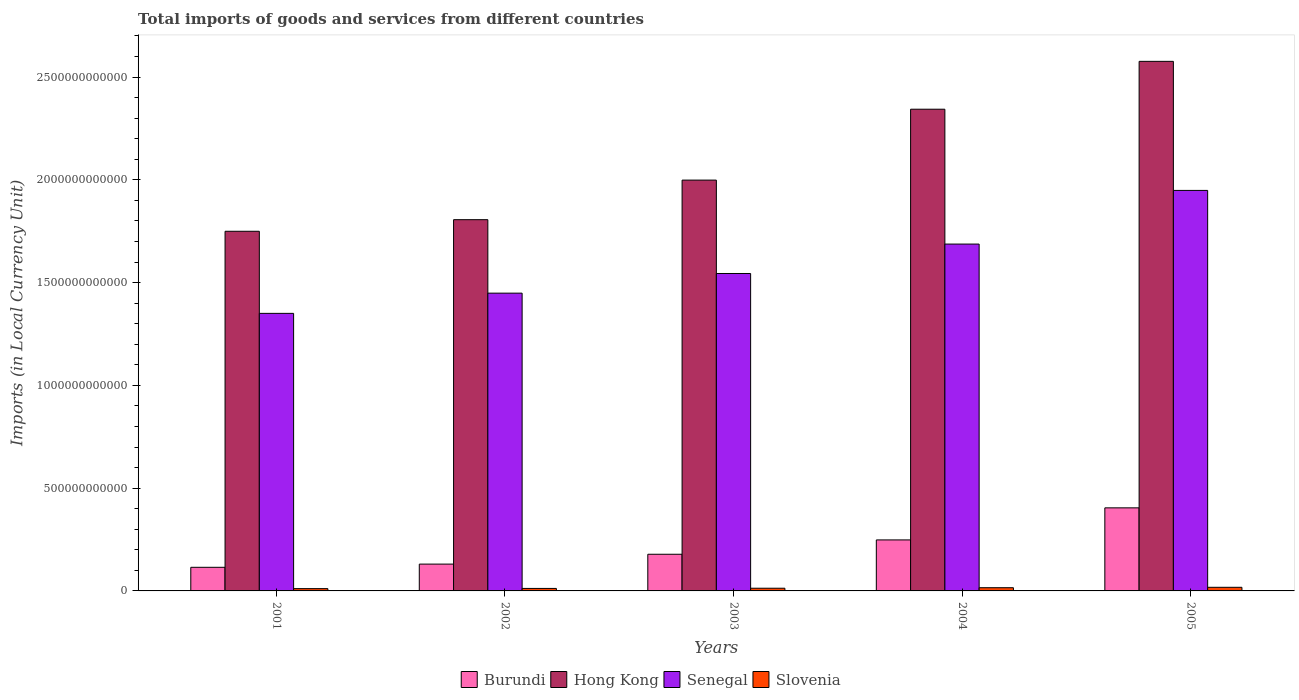How many different coloured bars are there?
Your answer should be very brief. 4. How many groups of bars are there?
Give a very brief answer. 5. How many bars are there on the 5th tick from the right?
Provide a succinct answer. 4. What is the label of the 4th group of bars from the left?
Your answer should be compact. 2004. In how many cases, is the number of bars for a given year not equal to the number of legend labels?
Give a very brief answer. 0. What is the Amount of goods and services imports in Hong Kong in 2001?
Give a very brief answer. 1.75e+12. Across all years, what is the maximum Amount of goods and services imports in Slovenia?
Provide a succinct answer. 1.76e+1. Across all years, what is the minimum Amount of goods and services imports in Senegal?
Your answer should be very brief. 1.35e+12. In which year was the Amount of goods and services imports in Hong Kong maximum?
Provide a short and direct response. 2005. What is the total Amount of goods and services imports in Slovenia in the graph?
Provide a succinct answer. 6.96e+1. What is the difference between the Amount of goods and services imports in Hong Kong in 2001 and that in 2003?
Keep it short and to the point. -2.49e+11. What is the difference between the Amount of goods and services imports in Burundi in 2003 and the Amount of goods and services imports in Slovenia in 2001?
Provide a succinct answer. 1.67e+11. What is the average Amount of goods and services imports in Burundi per year?
Offer a terse response. 2.15e+11. In the year 2001, what is the difference between the Amount of goods and services imports in Hong Kong and Amount of goods and services imports in Senegal?
Your response must be concise. 3.99e+11. What is the ratio of the Amount of goods and services imports in Senegal in 2001 to that in 2003?
Keep it short and to the point. 0.87. Is the Amount of goods and services imports in Senegal in 2003 less than that in 2004?
Your answer should be very brief. Yes. Is the difference between the Amount of goods and services imports in Hong Kong in 2003 and 2004 greater than the difference between the Amount of goods and services imports in Senegal in 2003 and 2004?
Keep it short and to the point. No. What is the difference between the highest and the second highest Amount of goods and services imports in Hong Kong?
Offer a very short reply. 2.33e+11. What is the difference between the highest and the lowest Amount of goods and services imports in Slovenia?
Provide a short and direct response. 6.44e+09. What does the 1st bar from the left in 2002 represents?
Ensure brevity in your answer.  Burundi. What does the 1st bar from the right in 2003 represents?
Ensure brevity in your answer.  Slovenia. Is it the case that in every year, the sum of the Amount of goods and services imports in Senegal and Amount of goods and services imports in Hong Kong is greater than the Amount of goods and services imports in Slovenia?
Your answer should be very brief. Yes. How many bars are there?
Give a very brief answer. 20. Are all the bars in the graph horizontal?
Offer a very short reply. No. What is the difference between two consecutive major ticks on the Y-axis?
Provide a succinct answer. 5.00e+11. Where does the legend appear in the graph?
Ensure brevity in your answer.  Bottom center. How are the legend labels stacked?
Make the answer very short. Horizontal. What is the title of the graph?
Ensure brevity in your answer.  Total imports of goods and services from different countries. What is the label or title of the Y-axis?
Make the answer very short. Imports (in Local Currency Unit). What is the Imports (in Local Currency Unit) of Burundi in 2001?
Provide a short and direct response. 1.15e+11. What is the Imports (in Local Currency Unit) of Hong Kong in 2001?
Give a very brief answer. 1.75e+12. What is the Imports (in Local Currency Unit) of Senegal in 2001?
Your answer should be compact. 1.35e+12. What is the Imports (in Local Currency Unit) in Slovenia in 2001?
Your answer should be compact. 1.12e+1. What is the Imports (in Local Currency Unit) of Burundi in 2002?
Provide a short and direct response. 1.31e+11. What is the Imports (in Local Currency Unit) in Hong Kong in 2002?
Ensure brevity in your answer.  1.81e+12. What is the Imports (in Local Currency Unit) in Senegal in 2002?
Make the answer very short. 1.45e+12. What is the Imports (in Local Currency Unit) of Slovenia in 2002?
Offer a very short reply. 1.21e+1. What is the Imports (in Local Currency Unit) in Burundi in 2003?
Offer a terse response. 1.78e+11. What is the Imports (in Local Currency Unit) of Hong Kong in 2003?
Keep it short and to the point. 2.00e+12. What is the Imports (in Local Currency Unit) in Senegal in 2003?
Provide a short and direct response. 1.54e+12. What is the Imports (in Local Currency Unit) of Slovenia in 2003?
Keep it short and to the point. 1.31e+1. What is the Imports (in Local Currency Unit) of Burundi in 2004?
Your answer should be very brief. 2.48e+11. What is the Imports (in Local Currency Unit) of Hong Kong in 2004?
Provide a succinct answer. 2.34e+12. What is the Imports (in Local Currency Unit) of Senegal in 2004?
Offer a very short reply. 1.69e+12. What is the Imports (in Local Currency Unit) of Slovenia in 2004?
Your answer should be very brief. 1.56e+1. What is the Imports (in Local Currency Unit) in Burundi in 2005?
Your response must be concise. 4.04e+11. What is the Imports (in Local Currency Unit) in Hong Kong in 2005?
Offer a terse response. 2.58e+12. What is the Imports (in Local Currency Unit) of Senegal in 2005?
Offer a terse response. 1.95e+12. What is the Imports (in Local Currency Unit) in Slovenia in 2005?
Your answer should be very brief. 1.76e+1. Across all years, what is the maximum Imports (in Local Currency Unit) in Burundi?
Your answer should be very brief. 4.04e+11. Across all years, what is the maximum Imports (in Local Currency Unit) in Hong Kong?
Offer a very short reply. 2.58e+12. Across all years, what is the maximum Imports (in Local Currency Unit) of Senegal?
Keep it short and to the point. 1.95e+12. Across all years, what is the maximum Imports (in Local Currency Unit) in Slovenia?
Ensure brevity in your answer.  1.76e+1. Across all years, what is the minimum Imports (in Local Currency Unit) in Burundi?
Your response must be concise. 1.15e+11. Across all years, what is the minimum Imports (in Local Currency Unit) of Hong Kong?
Give a very brief answer. 1.75e+12. Across all years, what is the minimum Imports (in Local Currency Unit) of Senegal?
Your answer should be very brief. 1.35e+12. Across all years, what is the minimum Imports (in Local Currency Unit) of Slovenia?
Ensure brevity in your answer.  1.12e+1. What is the total Imports (in Local Currency Unit) in Burundi in the graph?
Ensure brevity in your answer.  1.08e+12. What is the total Imports (in Local Currency Unit) in Hong Kong in the graph?
Make the answer very short. 1.05e+13. What is the total Imports (in Local Currency Unit) in Senegal in the graph?
Offer a terse response. 7.98e+12. What is the total Imports (in Local Currency Unit) of Slovenia in the graph?
Your answer should be compact. 6.96e+1. What is the difference between the Imports (in Local Currency Unit) of Burundi in 2001 and that in 2002?
Provide a short and direct response. -1.56e+1. What is the difference between the Imports (in Local Currency Unit) of Hong Kong in 2001 and that in 2002?
Your answer should be compact. -5.64e+1. What is the difference between the Imports (in Local Currency Unit) of Senegal in 2001 and that in 2002?
Your response must be concise. -9.83e+1. What is the difference between the Imports (in Local Currency Unit) in Slovenia in 2001 and that in 2002?
Your answer should be compact. -9.24e+08. What is the difference between the Imports (in Local Currency Unit) in Burundi in 2001 and that in 2003?
Provide a short and direct response. -6.34e+1. What is the difference between the Imports (in Local Currency Unit) in Hong Kong in 2001 and that in 2003?
Give a very brief answer. -2.49e+11. What is the difference between the Imports (in Local Currency Unit) in Senegal in 2001 and that in 2003?
Provide a succinct answer. -1.94e+11. What is the difference between the Imports (in Local Currency Unit) of Slovenia in 2001 and that in 2003?
Your answer should be very brief. -1.98e+09. What is the difference between the Imports (in Local Currency Unit) of Burundi in 2001 and that in 2004?
Your answer should be compact. -1.33e+11. What is the difference between the Imports (in Local Currency Unit) of Hong Kong in 2001 and that in 2004?
Your response must be concise. -5.94e+11. What is the difference between the Imports (in Local Currency Unit) of Senegal in 2001 and that in 2004?
Keep it short and to the point. -3.37e+11. What is the difference between the Imports (in Local Currency Unit) in Slovenia in 2001 and that in 2004?
Keep it short and to the point. -4.45e+09. What is the difference between the Imports (in Local Currency Unit) of Burundi in 2001 and that in 2005?
Ensure brevity in your answer.  -2.89e+11. What is the difference between the Imports (in Local Currency Unit) of Hong Kong in 2001 and that in 2005?
Offer a terse response. -8.27e+11. What is the difference between the Imports (in Local Currency Unit) in Senegal in 2001 and that in 2005?
Your answer should be very brief. -5.98e+11. What is the difference between the Imports (in Local Currency Unit) of Slovenia in 2001 and that in 2005?
Keep it short and to the point. -6.44e+09. What is the difference between the Imports (in Local Currency Unit) of Burundi in 2002 and that in 2003?
Provide a short and direct response. -4.78e+1. What is the difference between the Imports (in Local Currency Unit) in Hong Kong in 2002 and that in 2003?
Provide a short and direct response. -1.93e+11. What is the difference between the Imports (in Local Currency Unit) of Senegal in 2002 and that in 2003?
Offer a terse response. -9.56e+1. What is the difference between the Imports (in Local Currency Unit) in Slovenia in 2002 and that in 2003?
Your answer should be compact. -1.06e+09. What is the difference between the Imports (in Local Currency Unit) in Burundi in 2002 and that in 2004?
Make the answer very short. -1.18e+11. What is the difference between the Imports (in Local Currency Unit) in Hong Kong in 2002 and that in 2004?
Make the answer very short. -5.37e+11. What is the difference between the Imports (in Local Currency Unit) in Senegal in 2002 and that in 2004?
Make the answer very short. -2.39e+11. What is the difference between the Imports (in Local Currency Unit) in Slovenia in 2002 and that in 2004?
Offer a terse response. -3.52e+09. What is the difference between the Imports (in Local Currency Unit) of Burundi in 2002 and that in 2005?
Provide a succinct answer. -2.74e+11. What is the difference between the Imports (in Local Currency Unit) of Hong Kong in 2002 and that in 2005?
Your answer should be compact. -7.70e+11. What is the difference between the Imports (in Local Currency Unit) in Senegal in 2002 and that in 2005?
Offer a terse response. -5.00e+11. What is the difference between the Imports (in Local Currency Unit) of Slovenia in 2002 and that in 2005?
Ensure brevity in your answer.  -5.51e+09. What is the difference between the Imports (in Local Currency Unit) in Burundi in 2003 and that in 2004?
Provide a succinct answer. -6.98e+1. What is the difference between the Imports (in Local Currency Unit) of Hong Kong in 2003 and that in 2004?
Keep it short and to the point. -3.45e+11. What is the difference between the Imports (in Local Currency Unit) in Senegal in 2003 and that in 2004?
Ensure brevity in your answer.  -1.43e+11. What is the difference between the Imports (in Local Currency Unit) of Slovenia in 2003 and that in 2004?
Your response must be concise. -2.47e+09. What is the difference between the Imports (in Local Currency Unit) in Burundi in 2003 and that in 2005?
Offer a terse response. -2.26e+11. What is the difference between the Imports (in Local Currency Unit) of Hong Kong in 2003 and that in 2005?
Ensure brevity in your answer.  -5.78e+11. What is the difference between the Imports (in Local Currency Unit) of Senegal in 2003 and that in 2005?
Provide a succinct answer. -4.04e+11. What is the difference between the Imports (in Local Currency Unit) in Slovenia in 2003 and that in 2005?
Your answer should be compact. -4.45e+09. What is the difference between the Imports (in Local Currency Unit) of Burundi in 2004 and that in 2005?
Offer a terse response. -1.56e+11. What is the difference between the Imports (in Local Currency Unit) of Hong Kong in 2004 and that in 2005?
Your answer should be very brief. -2.33e+11. What is the difference between the Imports (in Local Currency Unit) of Senegal in 2004 and that in 2005?
Make the answer very short. -2.61e+11. What is the difference between the Imports (in Local Currency Unit) in Slovenia in 2004 and that in 2005?
Offer a very short reply. -1.99e+09. What is the difference between the Imports (in Local Currency Unit) of Burundi in 2001 and the Imports (in Local Currency Unit) of Hong Kong in 2002?
Offer a terse response. -1.69e+12. What is the difference between the Imports (in Local Currency Unit) of Burundi in 2001 and the Imports (in Local Currency Unit) of Senegal in 2002?
Provide a succinct answer. -1.33e+12. What is the difference between the Imports (in Local Currency Unit) in Burundi in 2001 and the Imports (in Local Currency Unit) in Slovenia in 2002?
Your answer should be very brief. 1.03e+11. What is the difference between the Imports (in Local Currency Unit) of Hong Kong in 2001 and the Imports (in Local Currency Unit) of Senegal in 2002?
Your response must be concise. 3.01e+11. What is the difference between the Imports (in Local Currency Unit) of Hong Kong in 2001 and the Imports (in Local Currency Unit) of Slovenia in 2002?
Keep it short and to the point. 1.74e+12. What is the difference between the Imports (in Local Currency Unit) of Senegal in 2001 and the Imports (in Local Currency Unit) of Slovenia in 2002?
Ensure brevity in your answer.  1.34e+12. What is the difference between the Imports (in Local Currency Unit) of Burundi in 2001 and the Imports (in Local Currency Unit) of Hong Kong in 2003?
Make the answer very short. -1.88e+12. What is the difference between the Imports (in Local Currency Unit) of Burundi in 2001 and the Imports (in Local Currency Unit) of Senegal in 2003?
Provide a short and direct response. -1.43e+12. What is the difference between the Imports (in Local Currency Unit) in Burundi in 2001 and the Imports (in Local Currency Unit) in Slovenia in 2003?
Ensure brevity in your answer.  1.02e+11. What is the difference between the Imports (in Local Currency Unit) in Hong Kong in 2001 and the Imports (in Local Currency Unit) in Senegal in 2003?
Your answer should be compact. 2.05e+11. What is the difference between the Imports (in Local Currency Unit) of Hong Kong in 2001 and the Imports (in Local Currency Unit) of Slovenia in 2003?
Provide a succinct answer. 1.74e+12. What is the difference between the Imports (in Local Currency Unit) in Senegal in 2001 and the Imports (in Local Currency Unit) in Slovenia in 2003?
Your answer should be compact. 1.34e+12. What is the difference between the Imports (in Local Currency Unit) of Burundi in 2001 and the Imports (in Local Currency Unit) of Hong Kong in 2004?
Offer a terse response. -2.23e+12. What is the difference between the Imports (in Local Currency Unit) in Burundi in 2001 and the Imports (in Local Currency Unit) in Senegal in 2004?
Ensure brevity in your answer.  -1.57e+12. What is the difference between the Imports (in Local Currency Unit) in Burundi in 2001 and the Imports (in Local Currency Unit) in Slovenia in 2004?
Your answer should be compact. 9.93e+1. What is the difference between the Imports (in Local Currency Unit) in Hong Kong in 2001 and the Imports (in Local Currency Unit) in Senegal in 2004?
Provide a succinct answer. 6.23e+1. What is the difference between the Imports (in Local Currency Unit) of Hong Kong in 2001 and the Imports (in Local Currency Unit) of Slovenia in 2004?
Give a very brief answer. 1.73e+12. What is the difference between the Imports (in Local Currency Unit) in Senegal in 2001 and the Imports (in Local Currency Unit) in Slovenia in 2004?
Your answer should be compact. 1.33e+12. What is the difference between the Imports (in Local Currency Unit) of Burundi in 2001 and the Imports (in Local Currency Unit) of Hong Kong in 2005?
Give a very brief answer. -2.46e+12. What is the difference between the Imports (in Local Currency Unit) of Burundi in 2001 and the Imports (in Local Currency Unit) of Senegal in 2005?
Offer a very short reply. -1.83e+12. What is the difference between the Imports (in Local Currency Unit) of Burundi in 2001 and the Imports (in Local Currency Unit) of Slovenia in 2005?
Offer a terse response. 9.73e+1. What is the difference between the Imports (in Local Currency Unit) in Hong Kong in 2001 and the Imports (in Local Currency Unit) in Senegal in 2005?
Your response must be concise. -1.99e+11. What is the difference between the Imports (in Local Currency Unit) of Hong Kong in 2001 and the Imports (in Local Currency Unit) of Slovenia in 2005?
Your response must be concise. 1.73e+12. What is the difference between the Imports (in Local Currency Unit) of Senegal in 2001 and the Imports (in Local Currency Unit) of Slovenia in 2005?
Provide a short and direct response. 1.33e+12. What is the difference between the Imports (in Local Currency Unit) of Burundi in 2002 and the Imports (in Local Currency Unit) of Hong Kong in 2003?
Your answer should be very brief. -1.87e+12. What is the difference between the Imports (in Local Currency Unit) of Burundi in 2002 and the Imports (in Local Currency Unit) of Senegal in 2003?
Offer a terse response. -1.41e+12. What is the difference between the Imports (in Local Currency Unit) of Burundi in 2002 and the Imports (in Local Currency Unit) of Slovenia in 2003?
Give a very brief answer. 1.17e+11. What is the difference between the Imports (in Local Currency Unit) in Hong Kong in 2002 and the Imports (in Local Currency Unit) in Senegal in 2003?
Keep it short and to the point. 2.62e+11. What is the difference between the Imports (in Local Currency Unit) in Hong Kong in 2002 and the Imports (in Local Currency Unit) in Slovenia in 2003?
Ensure brevity in your answer.  1.79e+12. What is the difference between the Imports (in Local Currency Unit) of Senegal in 2002 and the Imports (in Local Currency Unit) of Slovenia in 2003?
Provide a short and direct response. 1.44e+12. What is the difference between the Imports (in Local Currency Unit) in Burundi in 2002 and the Imports (in Local Currency Unit) in Hong Kong in 2004?
Give a very brief answer. -2.21e+12. What is the difference between the Imports (in Local Currency Unit) of Burundi in 2002 and the Imports (in Local Currency Unit) of Senegal in 2004?
Provide a short and direct response. -1.56e+12. What is the difference between the Imports (in Local Currency Unit) of Burundi in 2002 and the Imports (in Local Currency Unit) of Slovenia in 2004?
Your response must be concise. 1.15e+11. What is the difference between the Imports (in Local Currency Unit) of Hong Kong in 2002 and the Imports (in Local Currency Unit) of Senegal in 2004?
Your answer should be very brief. 1.19e+11. What is the difference between the Imports (in Local Currency Unit) in Hong Kong in 2002 and the Imports (in Local Currency Unit) in Slovenia in 2004?
Your answer should be compact. 1.79e+12. What is the difference between the Imports (in Local Currency Unit) in Senegal in 2002 and the Imports (in Local Currency Unit) in Slovenia in 2004?
Give a very brief answer. 1.43e+12. What is the difference between the Imports (in Local Currency Unit) of Burundi in 2002 and the Imports (in Local Currency Unit) of Hong Kong in 2005?
Your answer should be very brief. -2.45e+12. What is the difference between the Imports (in Local Currency Unit) in Burundi in 2002 and the Imports (in Local Currency Unit) in Senegal in 2005?
Keep it short and to the point. -1.82e+12. What is the difference between the Imports (in Local Currency Unit) in Burundi in 2002 and the Imports (in Local Currency Unit) in Slovenia in 2005?
Offer a terse response. 1.13e+11. What is the difference between the Imports (in Local Currency Unit) of Hong Kong in 2002 and the Imports (in Local Currency Unit) of Senegal in 2005?
Offer a very short reply. -1.42e+11. What is the difference between the Imports (in Local Currency Unit) in Hong Kong in 2002 and the Imports (in Local Currency Unit) in Slovenia in 2005?
Your response must be concise. 1.79e+12. What is the difference between the Imports (in Local Currency Unit) in Senegal in 2002 and the Imports (in Local Currency Unit) in Slovenia in 2005?
Make the answer very short. 1.43e+12. What is the difference between the Imports (in Local Currency Unit) of Burundi in 2003 and the Imports (in Local Currency Unit) of Hong Kong in 2004?
Ensure brevity in your answer.  -2.17e+12. What is the difference between the Imports (in Local Currency Unit) in Burundi in 2003 and the Imports (in Local Currency Unit) in Senegal in 2004?
Offer a very short reply. -1.51e+12. What is the difference between the Imports (in Local Currency Unit) in Burundi in 2003 and the Imports (in Local Currency Unit) in Slovenia in 2004?
Your answer should be compact. 1.63e+11. What is the difference between the Imports (in Local Currency Unit) of Hong Kong in 2003 and the Imports (in Local Currency Unit) of Senegal in 2004?
Make the answer very short. 3.11e+11. What is the difference between the Imports (in Local Currency Unit) of Hong Kong in 2003 and the Imports (in Local Currency Unit) of Slovenia in 2004?
Provide a succinct answer. 1.98e+12. What is the difference between the Imports (in Local Currency Unit) in Senegal in 2003 and the Imports (in Local Currency Unit) in Slovenia in 2004?
Your response must be concise. 1.53e+12. What is the difference between the Imports (in Local Currency Unit) of Burundi in 2003 and the Imports (in Local Currency Unit) of Hong Kong in 2005?
Your answer should be compact. -2.40e+12. What is the difference between the Imports (in Local Currency Unit) in Burundi in 2003 and the Imports (in Local Currency Unit) in Senegal in 2005?
Ensure brevity in your answer.  -1.77e+12. What is the difference between the Imports (in Local Currency Unit) of Burundi in 2003 and the Imports (in Local Currency Unit) of Slovenia in 2005?
Your answer should be compact. 1.61e+11. What is the difference between the Imports (in Local Currency Unit) of Hong Kong in 2003 and the Imports (in Local Currency Unit) of Senegal in 2005?
Ensure brevity in your answer.  5.01e+1. What is the difference between the Imports (in Local Currency Unit) of Hong Kong in 2003 and the Imports (in Local Currency Unit) of Slovenia in 2005?
Offer a very short reply. 1.98e+12. What is the difference between the Imports (in Local Currency Unit) of Senegal in 2003 and the Imports (in Local Currency Unit) of Slovenia in 2005?
Keep it short and to the point. 1.53e+12. What is the difference between the Imports (in Local Currency Unit) of Burundi in 2004 and the Imports (in Local Currency Unit) of Hong Kong in 2005?
Provide a short and direct response. -2.33e+12. What is the difference between the Imports (in Local Currency Unit) of Burundi in 2004 and the Imports (in Local Currency Unit) of Senegal in 2005?
Ensure brevity in your answer.  -1.70e+12. What is the difference between the Imports (in Local Currency Unit) of Burundi in 2004 and the Imports (in Local Currency Unit) of Slovenia in 2005?
Make the answer very short. 2.31e+11. What is the difference between the Imports (in Local Currency Unit) of Hong Kong in 2004 and the Imports (in Local Currency Unit) of Senegal in 2005?
Keep it short and to the point. 3.95e+11. What is the difference between the Imports (in Local Currency Unit) of Hong Kong in 2004 and the Imports (in Local Currency Unit) of Slovenia in 2005?
Offer a terse response. 2.33e+12. What is the difference between the Imports (in Local Currency Unit) of Senegal in 2004 and the Imports (in Local Currency Unit) of Slovenia in 2005?
Offer a terse response. 1.67e+12. What is the average Imports (in Local Currency Unit) of Burundi per year?
Offer a very short reply. 2.15e+11. What is the average Imports (in Local Currency Unit) of Hong Kong per year?
Provide a succinct answer. 2.09e+12. What is the average Imports (in Local Currency Unit) of Senegal per year?
Offer a terse response. 1.60e+12. What is the average Imports (in Local Currency Unit) of Slovenia per year?
Your response must be concise. 1.39e+1. In the year 2001, what is the difference between the Imports (in Local Currency Unit) of Burundi and Imports (in Local Currency Unit) of Hong Kong?
Give a very brief answer. -1.63e+12. In the year 2001, what is the difference between the Imports (in Local Currency Unit) of Burundi and Imports (in Local Currency Unit) of Senegal?
Your answer should be very brief. -1.24e+12. In the year 2001, what is the difference between the Imports (in Local Currency Unit) in Burundi and Imports (in Local Currency Unit) in Slovenia?
Give a very brief answer. 1.04e+11. In the year 2001, what is the difference between the Imports (in Local Currency Unit) of Hong Kong and Imports (in Local Currency Unit) of Senegal?
Ensure brevity in your answer.  3.99e+11. In the year 2001, what is the difference between the Imports (in Local Currency Unit) in Hong Kong and Imports (in Local Currency Unit) in Slovenia?
Ensure brevity in your answer.  1.74e+12. In the year 2001, what is the difference between the Imports (in Local Currency Unit) of Senegal and Imports (in Local Currency Unit) of Slovenia?
Make the answer very short. 1.34e+12. In the year 2002, what is the difference between the Imports (in Local Currency Unit) in Burundi and Imports (in Local Currency Unit) in Hong Kong?
Your response must be concise. -1.68e+12. In the year 2002, what is the difference between the Imports (in Local Currency Unit) in Burundi and Imports (in Local Currency Unit) in Senegal?
Provide a short and direct response. -1.32e+12. In the year 2002, what is the difference between the Imports (in Local Currency Unit) in Burundi and Imports (in Local Currency Unit) in Slovenia?
Your response must be concise. 1.18e+11. In the year 2002, what is the difference between the Imports (in Local Currency Unit) in Hong Kong and Imports (in Local Currency Unit) in Senegal?
Offer a terse response. 3.57e+11. In the year 2002, what is the difference between the Imports (in Local Currency Unit) of Hong Kong and Imports (in Local Currency Unit) of Slovenia?
Your answer should be compact. 1.79e+12. In the year 2002, what is the difference between the Imports (in Local Currency Unit) in Senegal and Imports (in Local Currency Unit) in Slovenia?
Offer a very short reply. 1.44e+12. In the year 2003, what is the difference between the Imports (in Local Currency Unit) of Burundi and Imports (in Local Currency Unit) of Hong Kong?
Provide a succinct answer. -1.82e+12. In the year 2003, what is the difference between the Imports (in Local Currency Unit) of Burundi and Imports (in Local Currency Unit) of Senegal?
Ensure brevity in your answer.  -1.37e+12. In the year 2003, what is the difference between the Imports (in Local Currency Unit) of Burundi and Imports (in Local Currency Unit) of Slovenia?
Keep it short and to the point. 1.65e+11. In the year 2003, what is the difference between the Imports (in Local Currency Unit) in Hong Kong and Imports (in Local Currency Unit) in Senegal?
Ensure brevity in your answer.  4.54e+11. In the year 2003, what is the difference between the Imports (in Local Currency Unit) of Hong Kong and Imports (in Local Currency Unit) of Slovenia?
Offer a very short reply. 1.99e+12. In the year 2003, what is the difference between the Imports (in Local Currency Unit) of Senegal and Imports (in Local Currency Unit) of Slovenia?
Your response must be concise. 1.53e+12. In the year 2004, what is the difference between the Imports (in Local Currency Unit) in Burundi and Imports (in Local Currency Unit) in Hong Kong?
Ensure brevity in your answer.  -2.10e+12. In the year 2004, what is the difference between the Imports (in Local Currency Unit) of Burundi and Imports (in Local Currency Unit) of Senegal?
Your response must be concise. -1.44e+12. In the year 2004, what is the difference between the Imports (in Local Currency Unit) of Burundi and Imports (in Local Currency Unit) of Slovenia?
Your answer should be compact. 2.32e+11. In the year 2004, what is the difference between the Imports (in Local Currency Unit) in Hong Kong and Imports (in Local Currency Unit) in Senegal?
Offer a very short reply. 6.56e+11. In the year 2004, what is the difference between the Imports (in Local Currency Unit) of Hong Kong and Imports (in Local Currency Unit) of Slovenia?
Make the answer very short. 2.33e+12. In the year 2004, what is the difference between the Imports (in Local Currency Unit) of Senegal and Imports (in Local Currency Unit) of Slovenia?
Offer a terse response. 1.67e+12. In the year 2005, what is the difference between the Imports (in Local Currency Unit) of Burundi and Imports (in Local Currency Unit) of Hong Kong?
Provide a succinct answer. -2.17e+12. In the year 2005, what is the difference between the Imports (in Local Currency Unit) of Burundi and Imports (in Local Currency Unit) of Senegal?
Your response must be concise. -1.54e+12. In the year 2005, what is the difference between the Imports (in Local Currency Unit) in Burundi and Imports (in Local Currency Unit) in Slovenia?
Offer a terse response. 3.87e+11. In the year 2005, what is the difference between the Imports (in Local Currency Unit) in Hong Kong and Imports (in Local Currency Unit) in Senegal?
Your answer should be very brief. 6.28e+11. In the year 2005, what is the difference between the Imports (in Local Currency Unit) in Hong Kong and Imports (in Local Currency Unit) in Slovenia?
Your answer should be very brief. 2.56e+12. In the year 2005, what is the difference between the Imports (in Local Currency Unit) of Senegal and Imports (in Local Currency Unit) of Slovenia?
Your response must be concise. 1.93e+12. What is the ratio of the Imports (in Local Currency Unit) of Burundi in 2001 to that in 2002?
Provide a succinct answer. 0.88. What is the ratio of the Imports (in Local Currency Unit) in Hong Kong in 2001 to that in 2002?
Ensure brevity in your answer.  0.97. What is the ratio of the Imports (in Local Currency Unit) in Senegal in 2001 to that in 2002?
Provide a succinct answer. 0.93. What is the ratio of the Imports (in Local Currency Unit) in Slovenia in 2001 to that in 2002?
Give a very brief answer. 0.92. What is the ratio of the Imports (in Local Currency Unit) of Burundi in 2001 to that in 2003?
Give a very brief answer. 0.64. What is the ratio of the Imports (in Local Currency Unit) in Hong Kong in 2001 to that in 2003?
Provide a short and direct response. 0.88. What is the ratio of the Imports (in Local Currency Unit) of Senegal in 2001 to that in 2003?
Provide a short and direct response. 0.87. What is the ratio of the Imports (in Local Currency Unit) of Slovenia in 2001 to that in 2003?
Offer a very short reply. 0.85. What is the ratio of the Imports (in Local Currency Unit) of Burundi in 2001 to that in 2004?
Your response must be concise. 0.46. What is the ratio of the Imports (in Local Currency Unit) in Hong Kong in 2001 to that in 2004?
Your answer should be compact. 0.75. What is the ratio of the Imports (in Local Currency Unit) in Senegal in 2001 to that in 2004?
Ensure brevity in your answer.  0.8. What is the ratio of the Imports (in Local Currency Unit) of Slovenia in 2001 to that in 2004?
Provide a short and direct response. 0.72. What is the ratio of the Imports (in Local Currency Unit) of Burundi in 2001 to that in 2005?
Your answer should be compact. 0.28. What is the ratio of the Imports (in Local Currency Unit) of Hong Kong in 2001 to that in 2005?
Provide a succinct answer. 0.68. What is the ratio of the Imports (in Local Currency Unit) in Senegal in 2001 to that in 2005?
Ensure brevity in your answer.  0.69. What is the ratio of the Imports (in Local Currency Unit) of Slovenia in 2001 to that in 2005?
Offer a terse response. 0.63. What is the ratio of the Imports (in Local Currency Unit) in Burundi in 2002 to that in 2003?
Your answer should be very brief. 0.73. What is the ratio of the Imports (in Local Currency Unit) in Hong Kong in 2002 to that in 2003?
Make the answer very short. 0.9. What is the ratio of the Imports (in Local Currency Unit) in Senegal in 2002 to that in 2003?
Your answer should be very brief. 0.94. What is the ratio of the Imports (in Local Currency Unit) of Slovenia in 2002 to that in 2003?
Make the answer very short. 0.92. What is the ratio of the Imports (in Local Currency Unit) in Burundi in 2002 to that in 2004?
Give a very brief answer. 0.53. What is the ratio of the Imports (in Local Currency Unit) of Hong Kong in 2002 to that in 2004?
Your answer should be compact. 0.77. What is the ratio of the Imports (in Local Currency Unit) of Senegal in 2002 to that in 2004?
Offer a very short reply. 0.86. What is the ratio of the Imports (in Local Currency Unit) of Slovenia in 2002 to that in 2004?
Offer a very short reply. 0.77. What is the ratio of the Imports (in Local Currency Unit) in Burundi in 2002 to that in 2005?
Offer a very short reply. 0.32. What is the ratio of the Imports (in Local Currency Unit) in Hong Kong in 2002 to that in 2005?
Keep it short and to the point. 0.7. What is the ratio of the Imports (in Local Currency Unit) in Senegal in 2002 to that in 2005?
Give a very brief answer. 0.74. What is the ratio of the Imports (in Local Currency Unit) of Slovenia in 2002 to that in 2005?
Ensure brevity in your answer.  0.69. What is the ratio of the Imports (in Local Currency Unit) of Burundi in 2003 to that in 2004?
Your response must be concise. 0.72. What is the ratio of the Imports (in Local Currency Unit) of Hong Kong in 2003 to that in 2004?
Offer a very short reply. 0.85. What is the ratio of the Imports (in Local Currency Unit) of Senegal in 2003 to that in 2004?
Your answer should be very brief. 0.92. What is the ratio of the Imports (in Local Currency Unit) of Slovenia in 2003 to that in 2004?
Your answer should be very brief. 0.84. What is the ratio of the Imports (in Local Currency Unit) in Burundi in 2003 to that in 2005?
Offer a very short reply. 0.44. What is the ratio of the Imports (in Local Currency Unit) in Hong Kong in 2003 to that in 2005?
Provide a short and direct response. 0.78. What is the ratio of the Imports (in Local Currency Unit) of Senegal in 2003 to that in 2005?
Give a very brief answer. 0.79. What is the ratio of the Imports (in Local Currency Unit) in Slovenia in 2003 to that in 2005?
Provide a short and direct response. 0.75. What is the ratio of the Imports (in Local Currency Unit) of Burundi in 2004 to that in 2005?
Make the answer very short. 0.61. What is the ratio of the Imports (in Local Currency Unit) in Hong Kong in 2004 to that in 2005?
Your answer should be compact. 0.91. What is the ratio of the Imports (in Local Currency Unit) of Senegal in 2004 to that in 2005?
Offer a very short reply. 0.87. What is the ratio of the Imports (in Local Currency Unit) of Slovenia in 2004 to that in 2005?
Provide a succinct answer. 0.89. What is the difference between the highest and the second highest Imports (in Local Currency Unit) of Burundi?
Keep it short and to the point. 1.56e+11. What is the difference between the highest and the second highest Imports (in Local Currency Unit) of Hong Kong?
Give a very brief answer. 2.33e+11. What is the difference between the highest and the second highest Imports (in Local Currency Unit) of Senegal?
Offer a very short reply. 2.61e+11. What is the difference between the highest and the second highest Imports (in Local Currency Unit) in Slovenia?
Ensure brevity in your answer.  1.99e+09. What is the difference between the highest and the lowest Imports (in Local Currency Unit) of Burundi?
Provide a succinct answer. 2.89e+11. What is the difference between the highest and the lowest Imports (in Local Currency Unit) of Hong Kong?
Your response must be concise. 8.27e+11. What is the difference between the highest and the lowest Imports (in Local Currency Unit) in Senegal?
Offer a terse response. 5.98e+11. What is the difference between the highest and the lowest Imports (in Local Currency Unit) of Slovenia?
Offer a very short reply. 6.44e+09. 